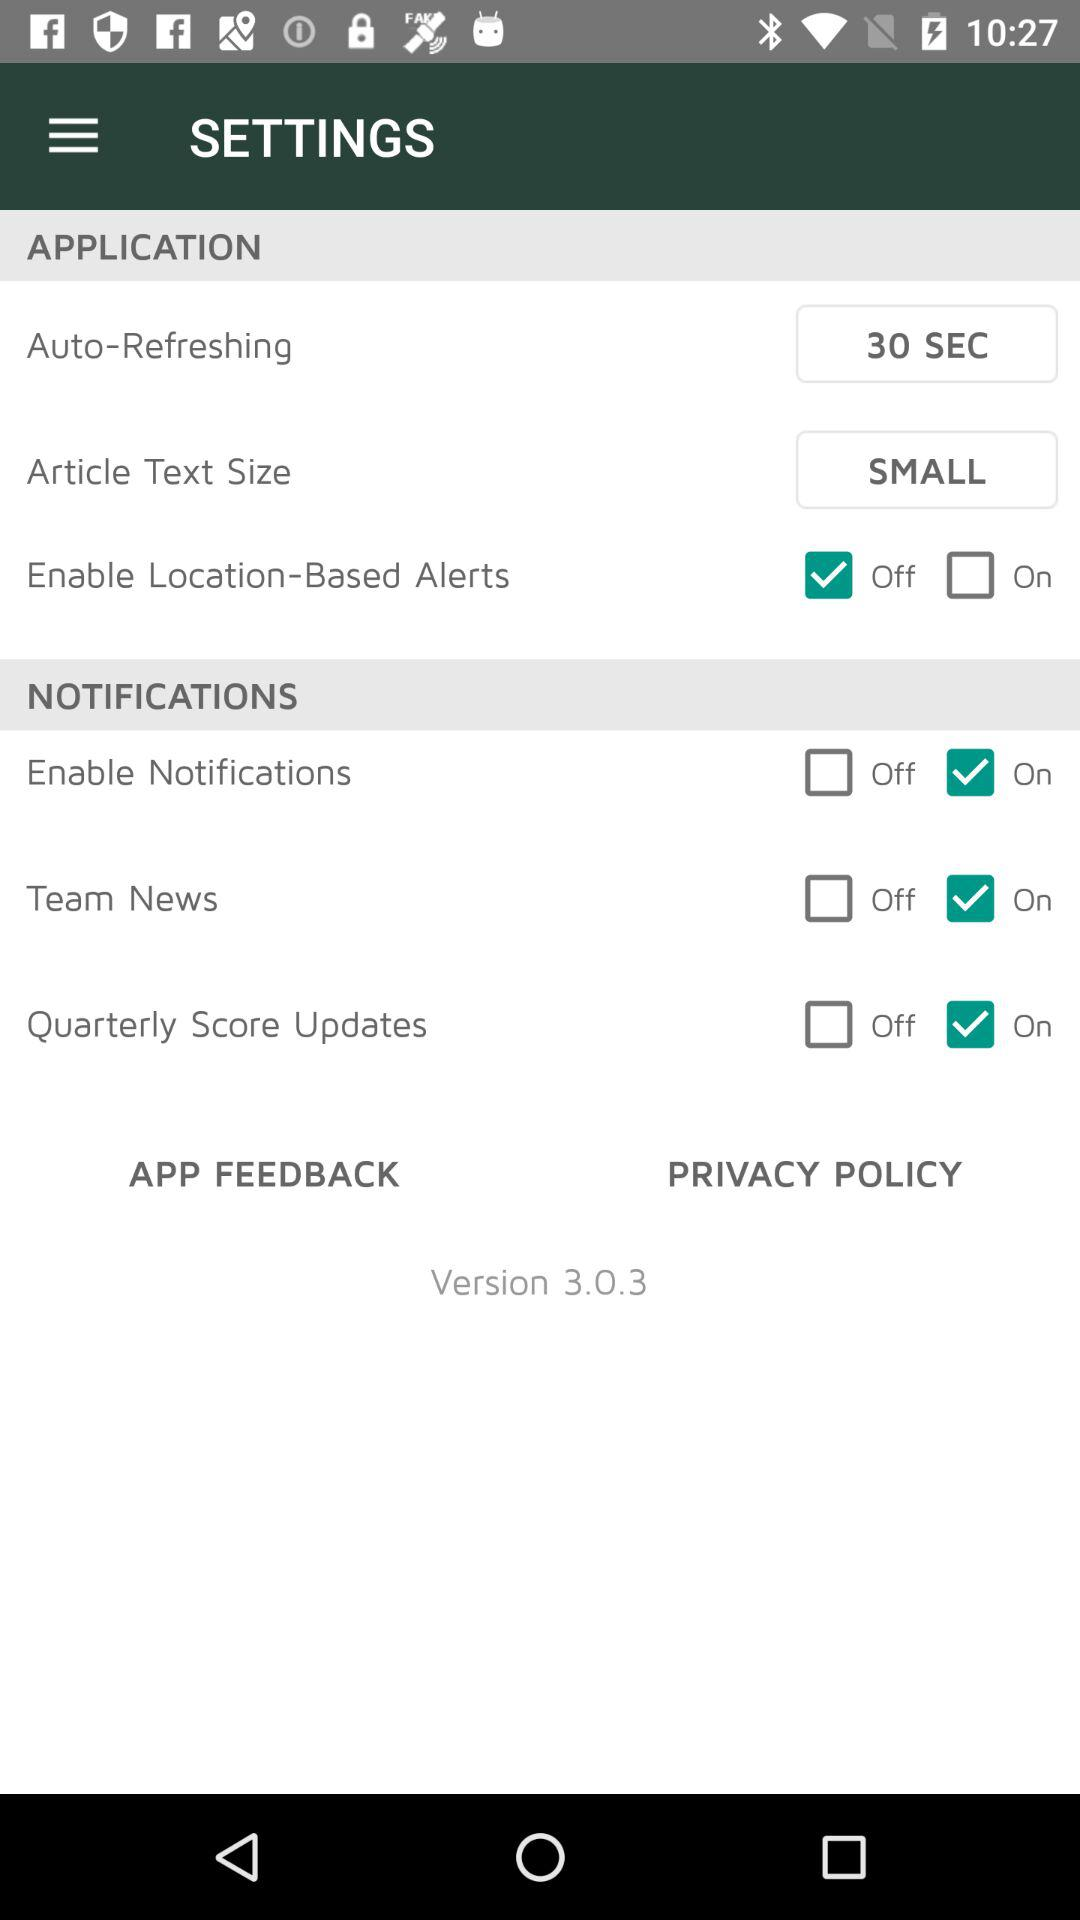What is the size of the article text? The size of the article text is small. 